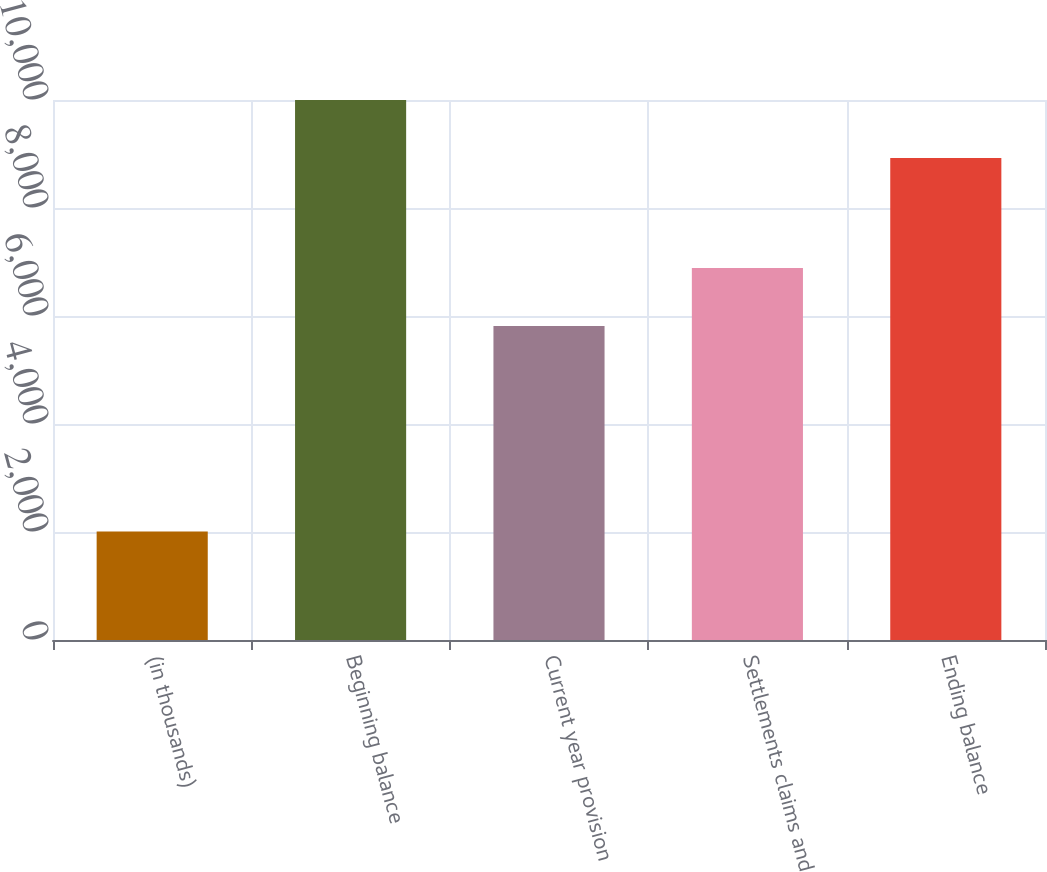<chart> <loc_0><loc_0><loc_500><loc_500><bar_chart><fcel>(in thousands)<fcel>Beginning balance<fcel>Current year provision<fcel>Settlements claims and<fcel>Ending balance<nl><fcel>2010<fcel>10000<fcel>5816<fcel>6891<fcel>8925<nl></chart> 